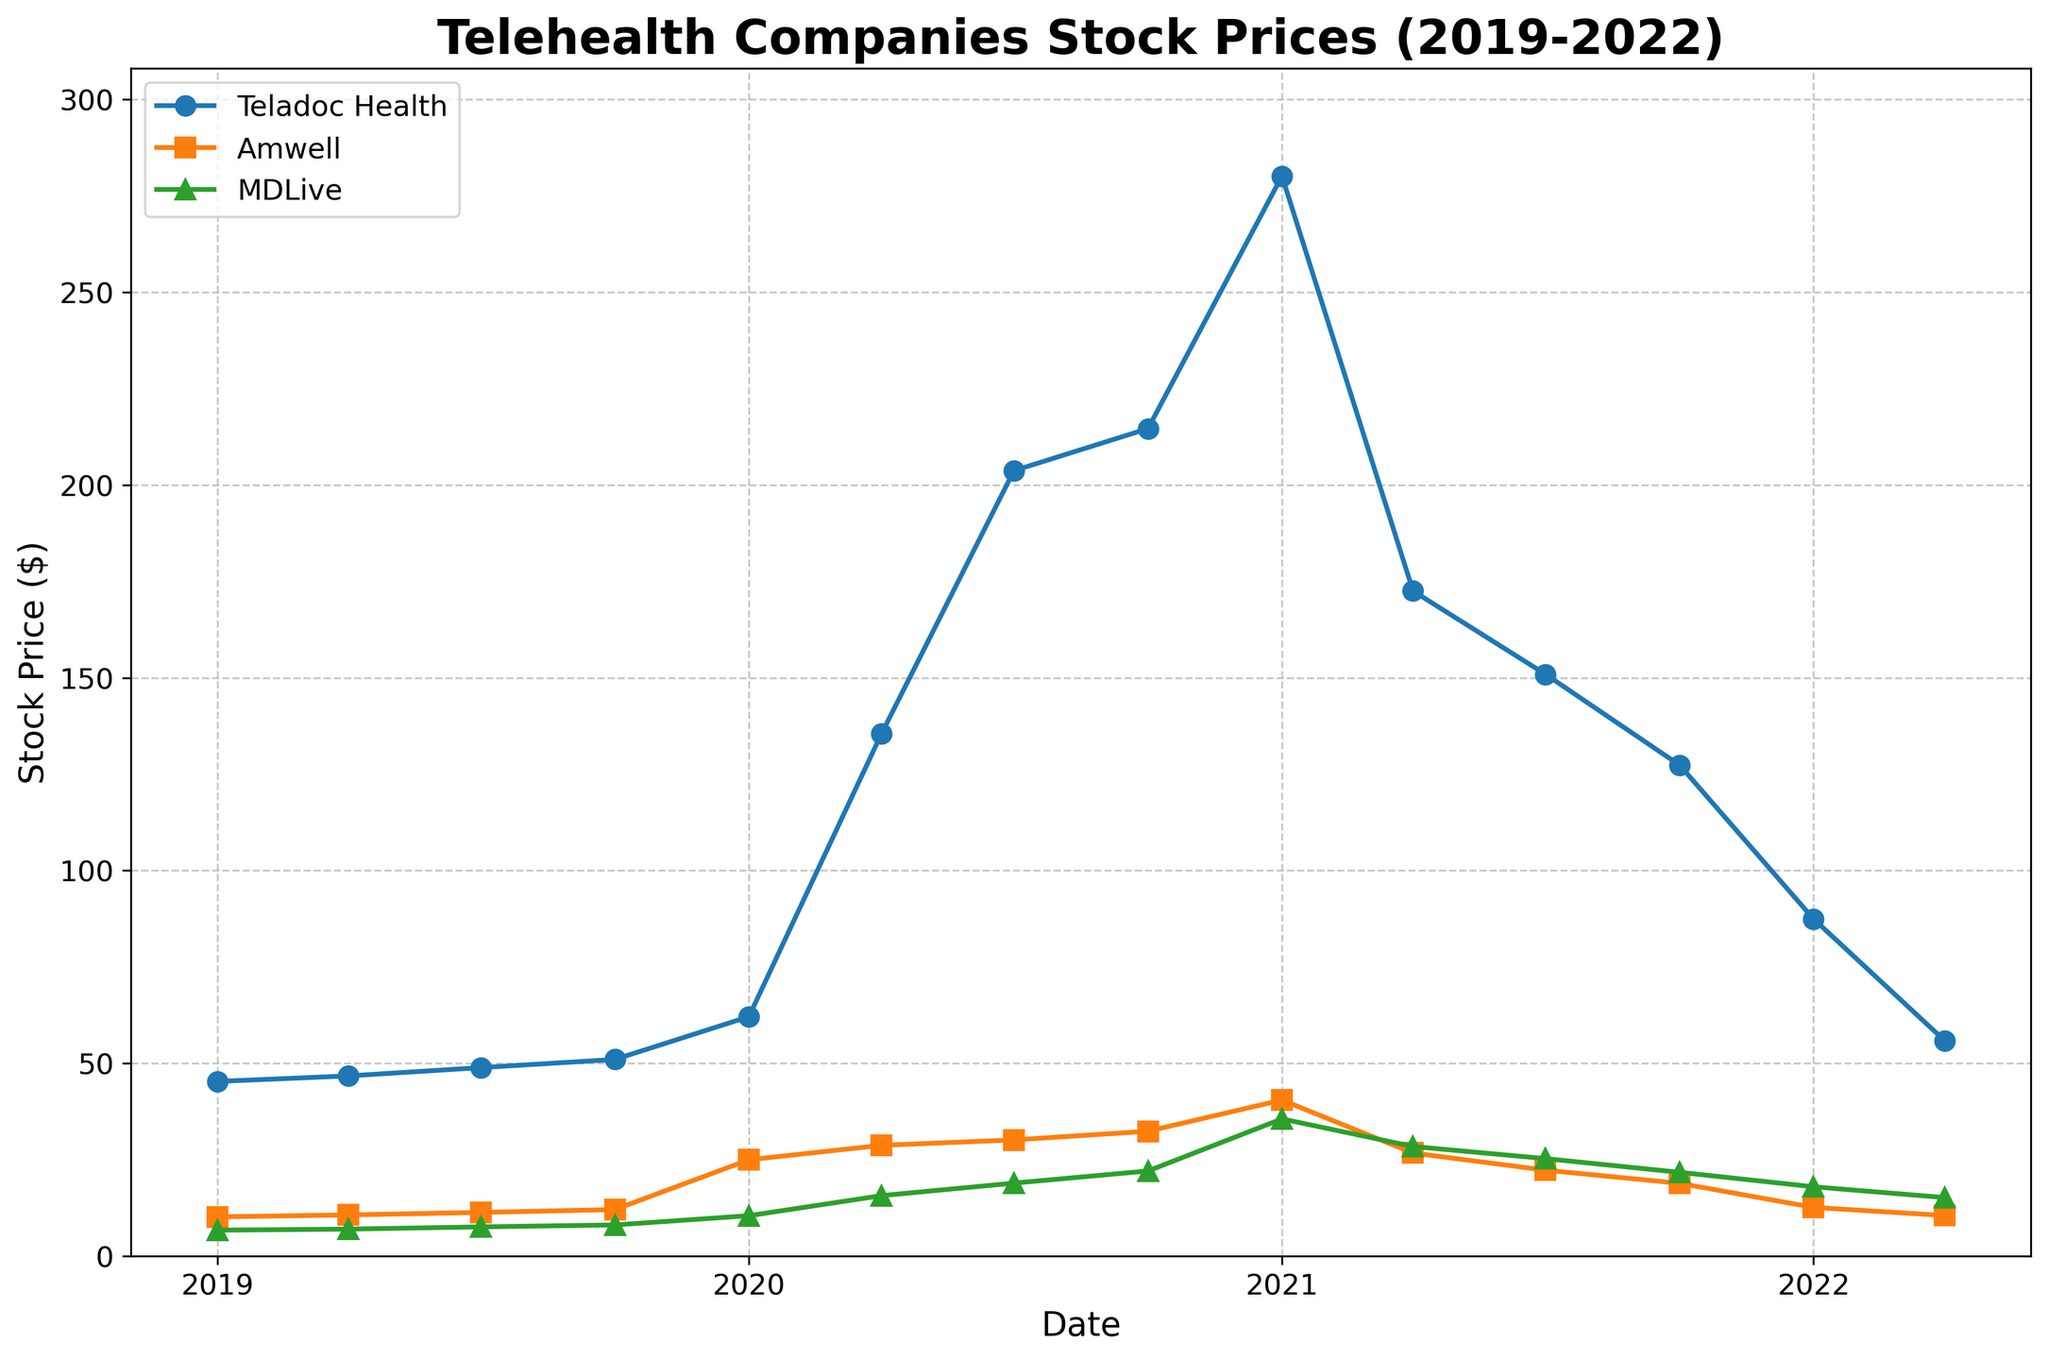What is the title of the figure? The title of the figure is displayed at the top. It reads, "Telehealth Companies Stock Prices (2019-2022)"
Answer: Telehealth Companies Stock Prices (2019-2022) Which company had the highest stock price in January 2021? Looking at the data points for January 2021, Teladoc Health had the highest stock price at 280.10
Answer: Teladoc Health How did Teladoc Health's stock price change from January 2020 to April 2020? By looking at the data points for January 2020 and April 2020, Teladoc Health's stock price jumped from 62.11 to 135.45. Subtracting the January price from the April price gives the change: 135.45 - 62.11 = 73.34
Answer: Increased by 73.34 Which company had the most significant drop in stock price from its peak to April 2022? Teladoc Health's peak was at 280.10 in January 2021, and its price in April 2022 was 55.90. The drop was 280.10 - 55.90 = 224.20, which is more significant compared to other companies' drops
Answer: Teladoc Health What was the trend in Amwell's stock price throughout 2021? Observing the data points for Amwell in 2021 - January (40.50), April (26.75), July (22.30), and October (18.90) - there is a clear declining trend throughout the year
Answer: Declining Which company had the smallest change in stock price from January 2019 to April 2022? For each company, calculate the difference between January 2019 and April 2022: Teladoc Health: 55.90 - 45.32 = 10.58, Amwell: 10.55 - 10.20 = 0.35, MDLive: 15.20 - 6.75 = 8.45. Amwell had the smallest change
Answer: Amwell How did the stock prices of all companies respond to the major health crisis starting in early 2020? By observing the trend from January 2020, there is a significant rise in stock prices for all companies (Teladoc at 62.11 jumping to 135.45, Amwell at 25.00 to 28.75, MDLive at 10.50 to 15.70). This indicates a sharp increase in response to the health crisis
Answer: Significant rise Which company's stock price was more stable throughout the observed period? By comparing the variations and trends, Amwell showed a more stable trend with smaller fluctuations as compared to Teladoc Health and MDLive which had larger spikes and drops
Answer: Amwell 